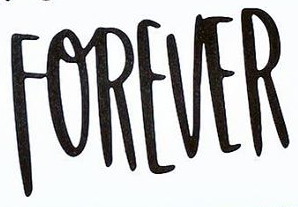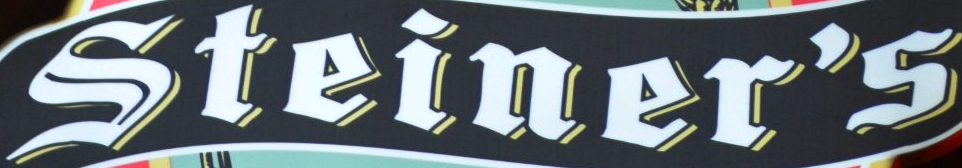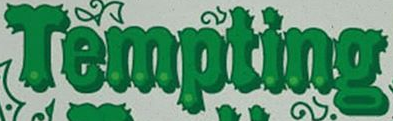What text is displayed in these images sequentially, separated by a semicolon? FOREVER; Steiner's; Tempting 